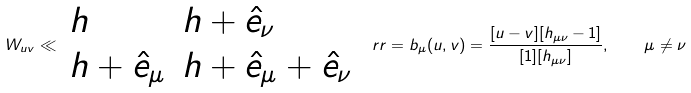Convert formula to latex. <formula><loc_0><loc_0><loc_500><loc_500>W _ { u v } \ll \begin{array} { l l } h & h + \hat { e } _ { \nu } \\ h + \hat { e } _ { \mu } & h + \hat { e } _ { \mu } + \hat { e } _ { \nu } \end{array} \ r r = b _ { \mu } ( u , v ) = \frac { [ u - v ] [ h _ { \mu \nu } - 1 ] } { [ 1 ] [ h _ { \mu \nu } ] } , \quad \mu \ne \nu</formula> 